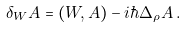Convert formula to latex. <formula><loc_0><loc_0><loc_500><loc_500>\delta _ { W } A = ( W , A ) - i \hbar { \Delta } _ { \rho } { A } \, .</formula> 